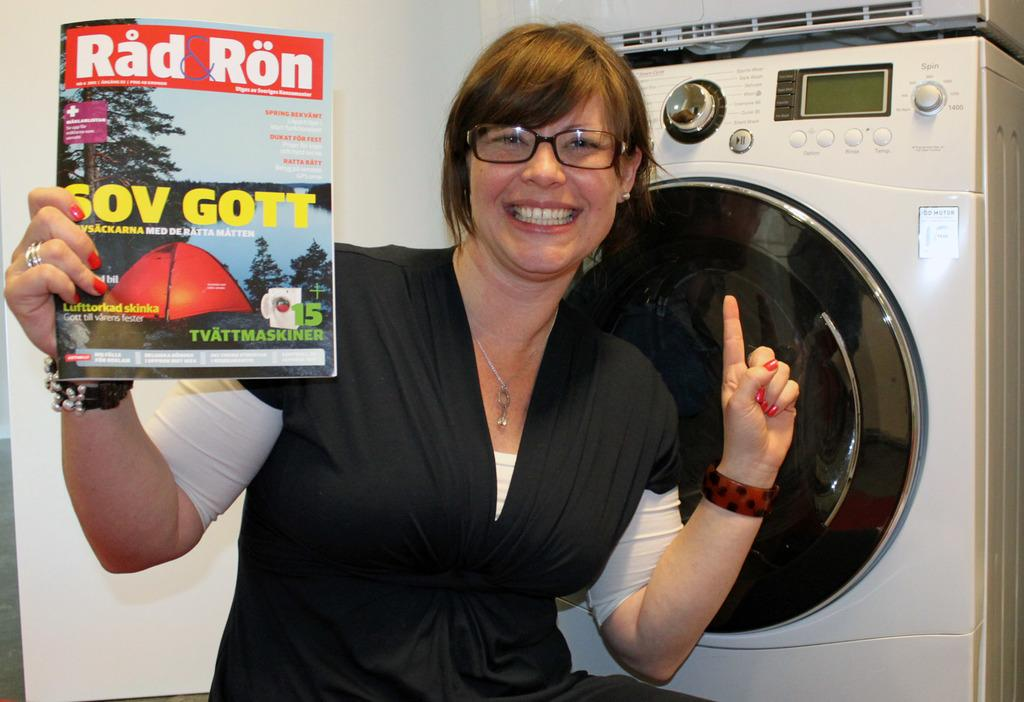<image>
Write a terse but informative summary of the picture. A woman happily holds a copy of Rad Ron magazine. 